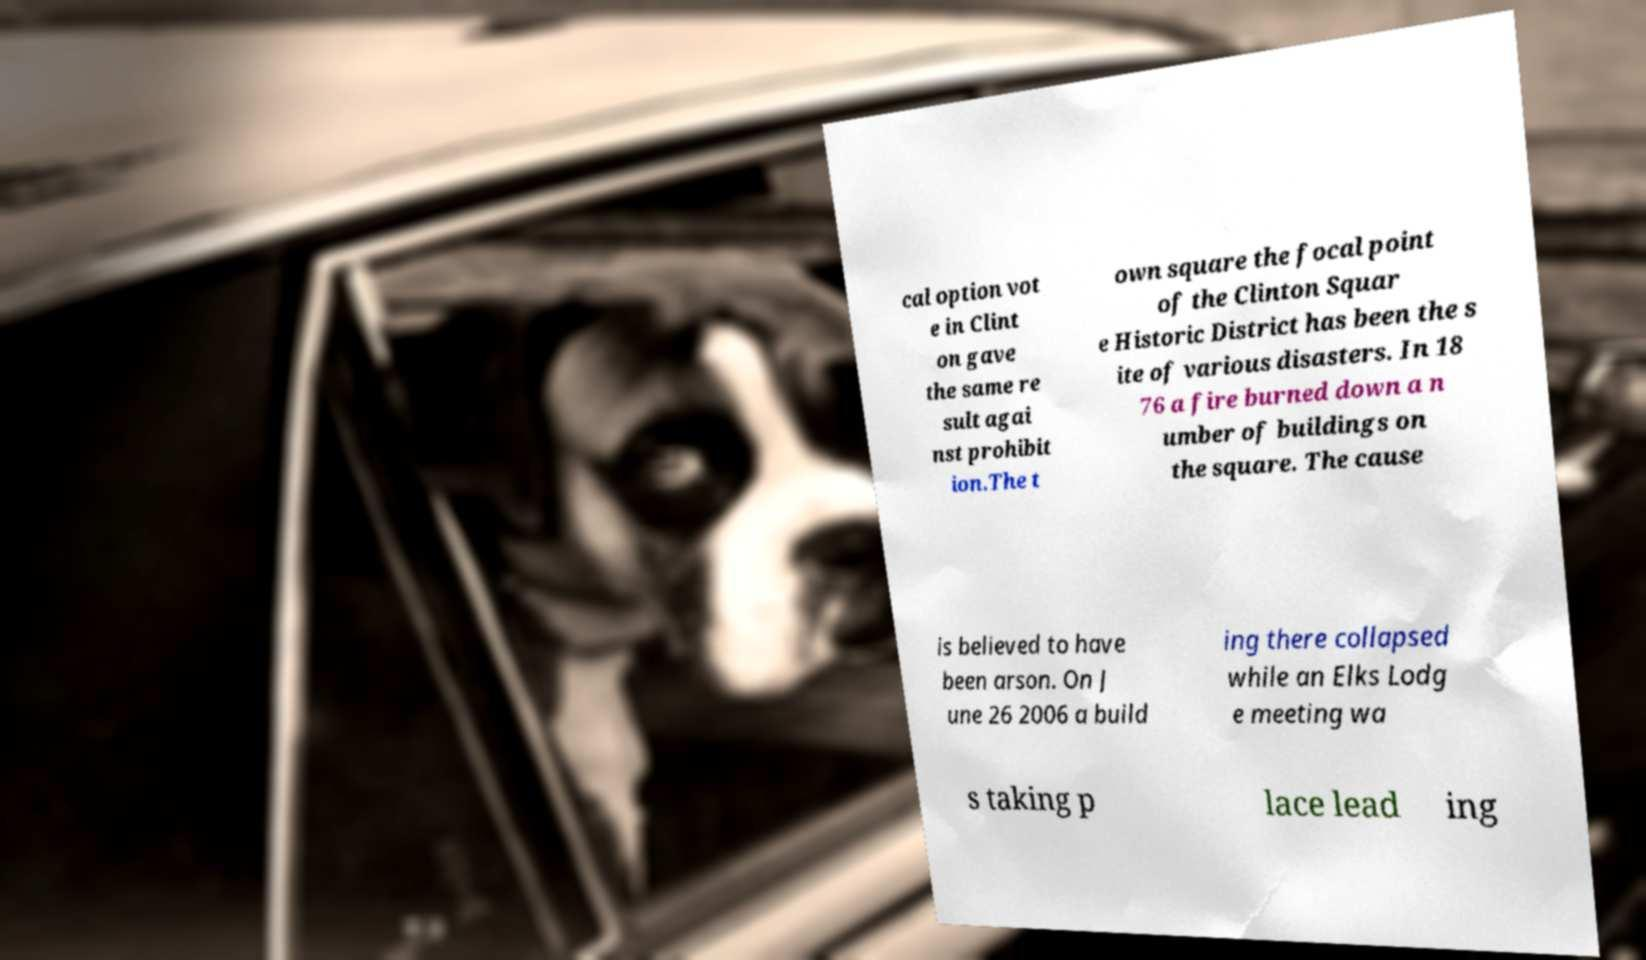Please read and relay the text visible in this image. What does it say? cal option vot e in Clint on gave the same re sult agai nst prohibit ion.The t own square the focal point of the Clinton Squar e Historic District has been the s ite of various disasters. In 18 76 a fire burned down a n umber of buildings on the square. The cause is believed to have been arson. On J une 26 2006 a build ing there collapsed while an Elks Lodg e meeting wa s taking p lace lead ing 